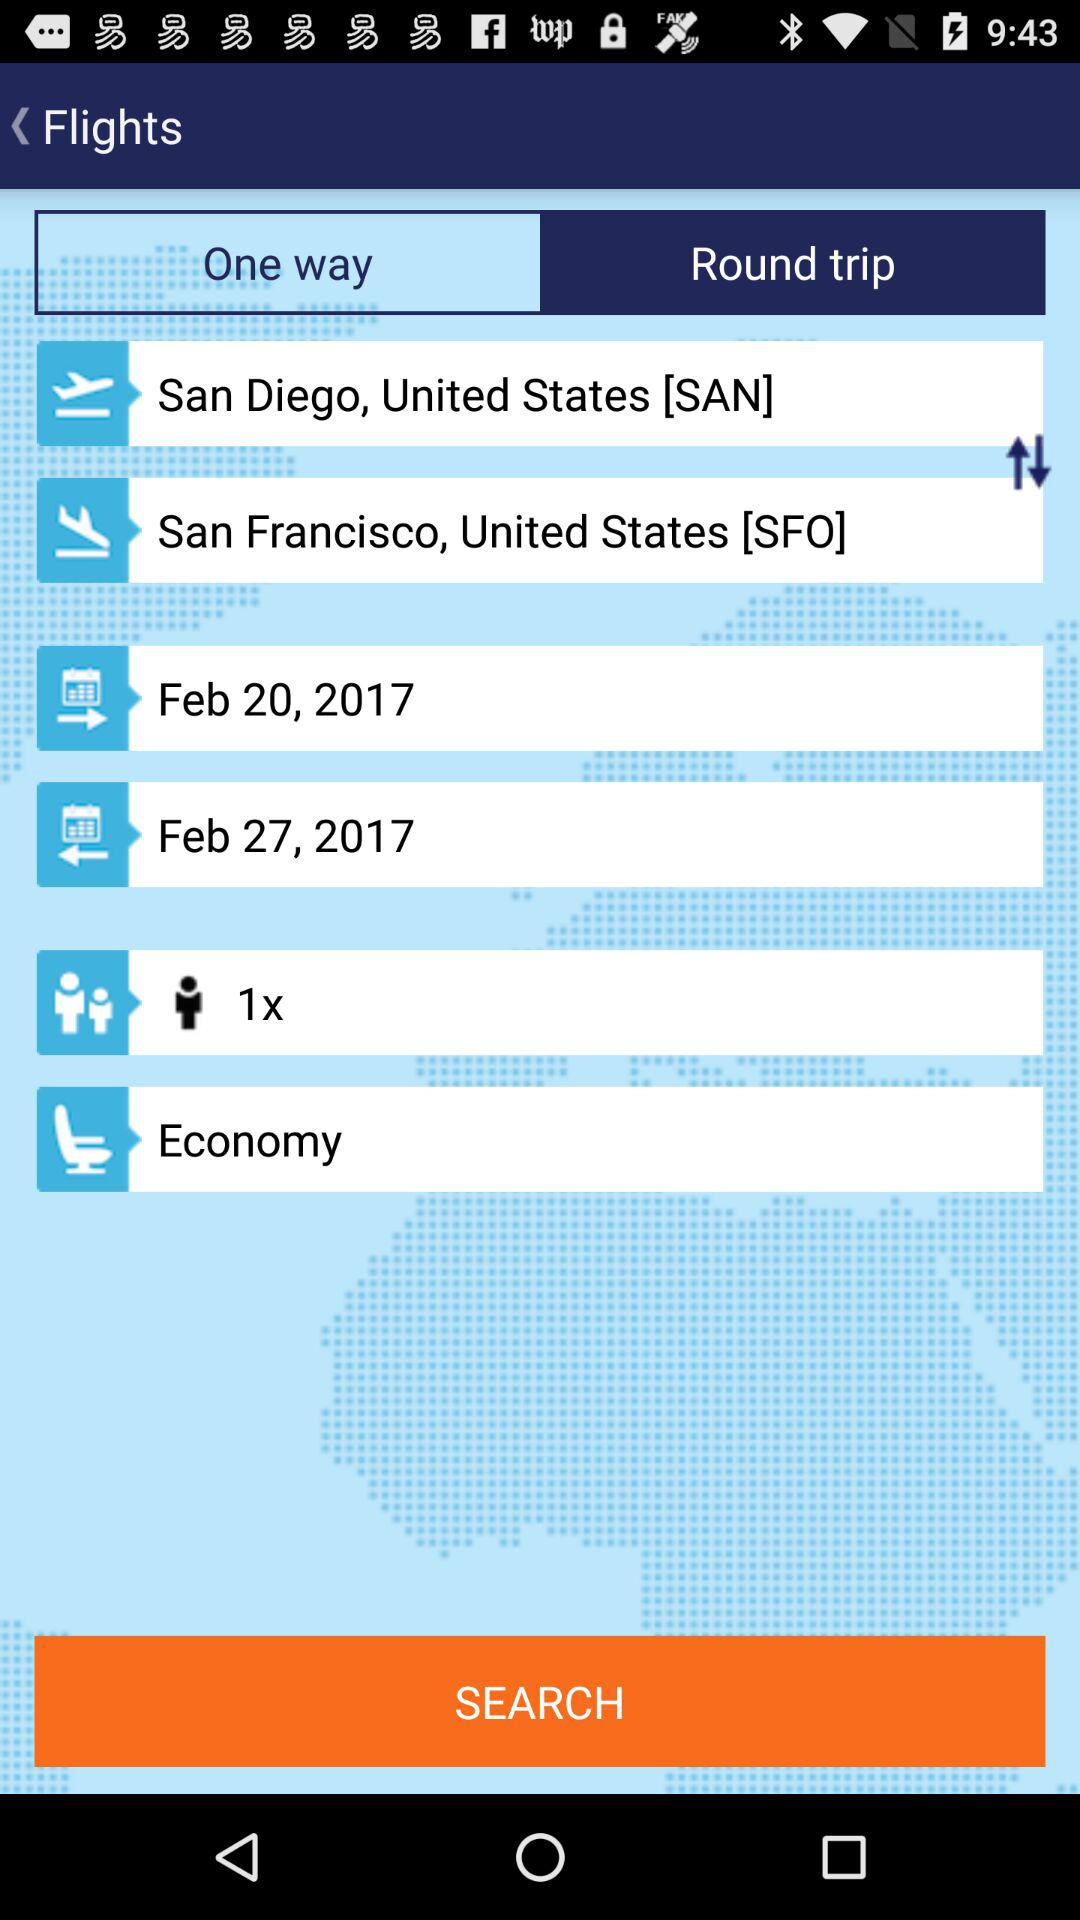What is the flight's start date? The flight's start date is Feb 20, 2017. 